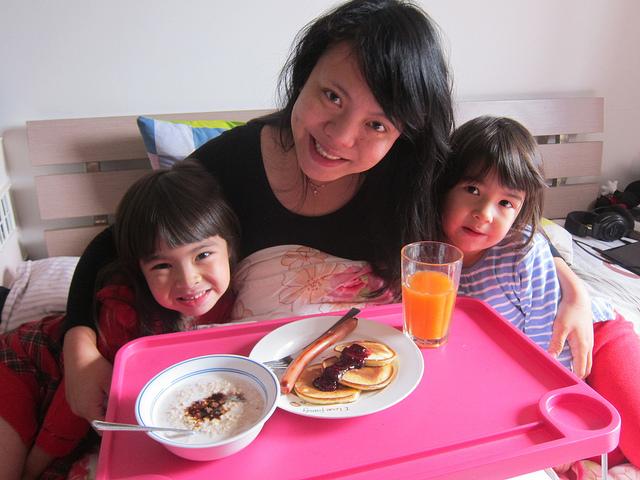What is holding their food?
Concise answer only. Tray. Is there a bowl of cereal on the tray?
Write a very short answer. Yes. What color is the tray?
Answer briefly. Pink. 